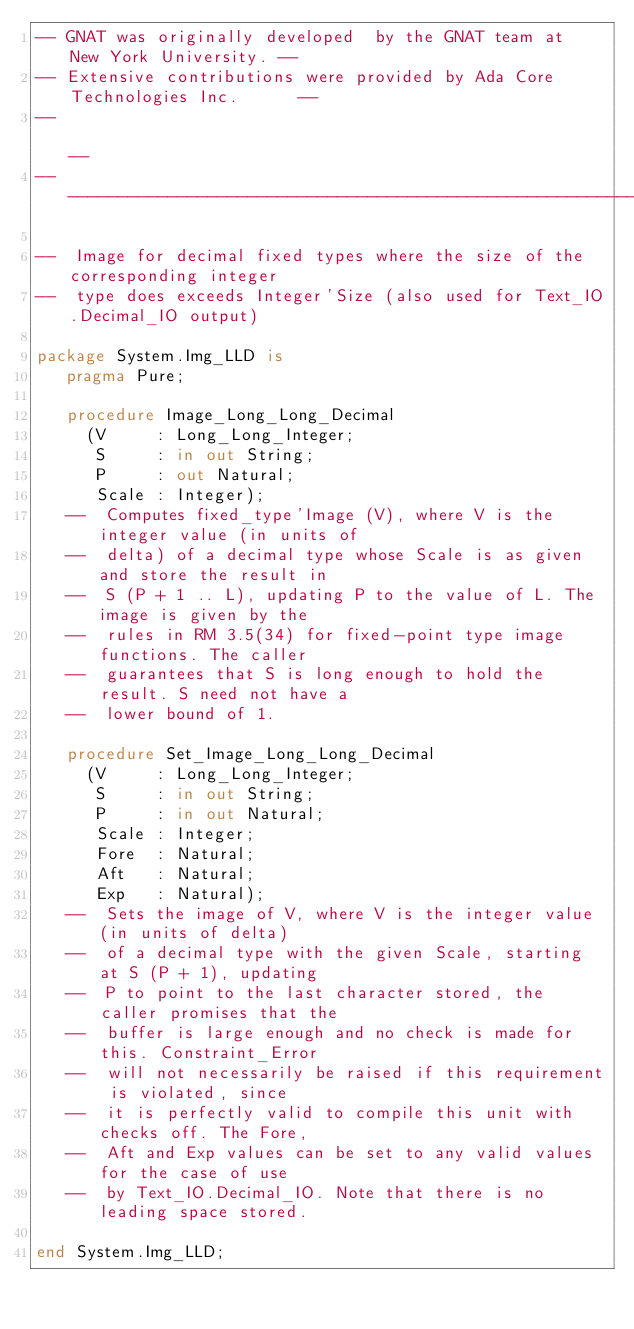<code> <loc_0><loc_0><loc_500><loc_500><_Ada_>-- GNAT was originally developed  by the GNAT team at  New York University. --
-- Extensive contributions were provided by Ada Core Technologies Inc.      --
--                                                                          --
------------------------------------------------------------------------------

--  Image for decimal fixed types where the size of the corresponding integer
--  type does exceeds Integer'Size (also used for Text_IO.Decimal_IO output)

package System.Img_LLD is
   pragma Pure;

   procedure Image_Long_Long_Decimal
     (V     : Long_Long_Integer;
      S     : in out String;
      P     : out Natural;
      Scale : Integer);
   --  Computes fixed_type'Image (V), where V is the integer value (in units of
   --  delta) of a decimal type whose Scale is as given and store the result in
   --  S (P + 1 .. L), updating P to the value of L. The image is given by the
   --  rules in RM 3.5(34) for fixed-point type image functions. The caller
   --  guarantees that S is long enough to hold the result. S need not have a
   --  lower bound of 1.

   procedure Set_Image_Long_Long_Decimal
     (V     : Long_Long_Integer;
      S     : in out String;
      P     : in out Natural;
      Scale : Integer;
      Fore  : Natural;
      Aft   : Natural;
      Exp   : Natural);
   --  Sets the image of V, where V is the integer value (in units of delta)
   --  of a decimal type with the given Scale, starting at S (P + 1), updating
   --  P to point to the last character stored, the caller promises that the
   --  buffer is large enough and no check is made for this. Constraint_Error
   --  will not necessarily be raised if this requirement is violated, since
   --  it is perfectly valid to compile this unit with checks off. The Fore,
   --  Aft and Exp values can be set to any valid values for the case of use
   --  by Text_IO.Decimal_IO. Note that there is no leading space stored.

end System.Img_LLD;
</code> 